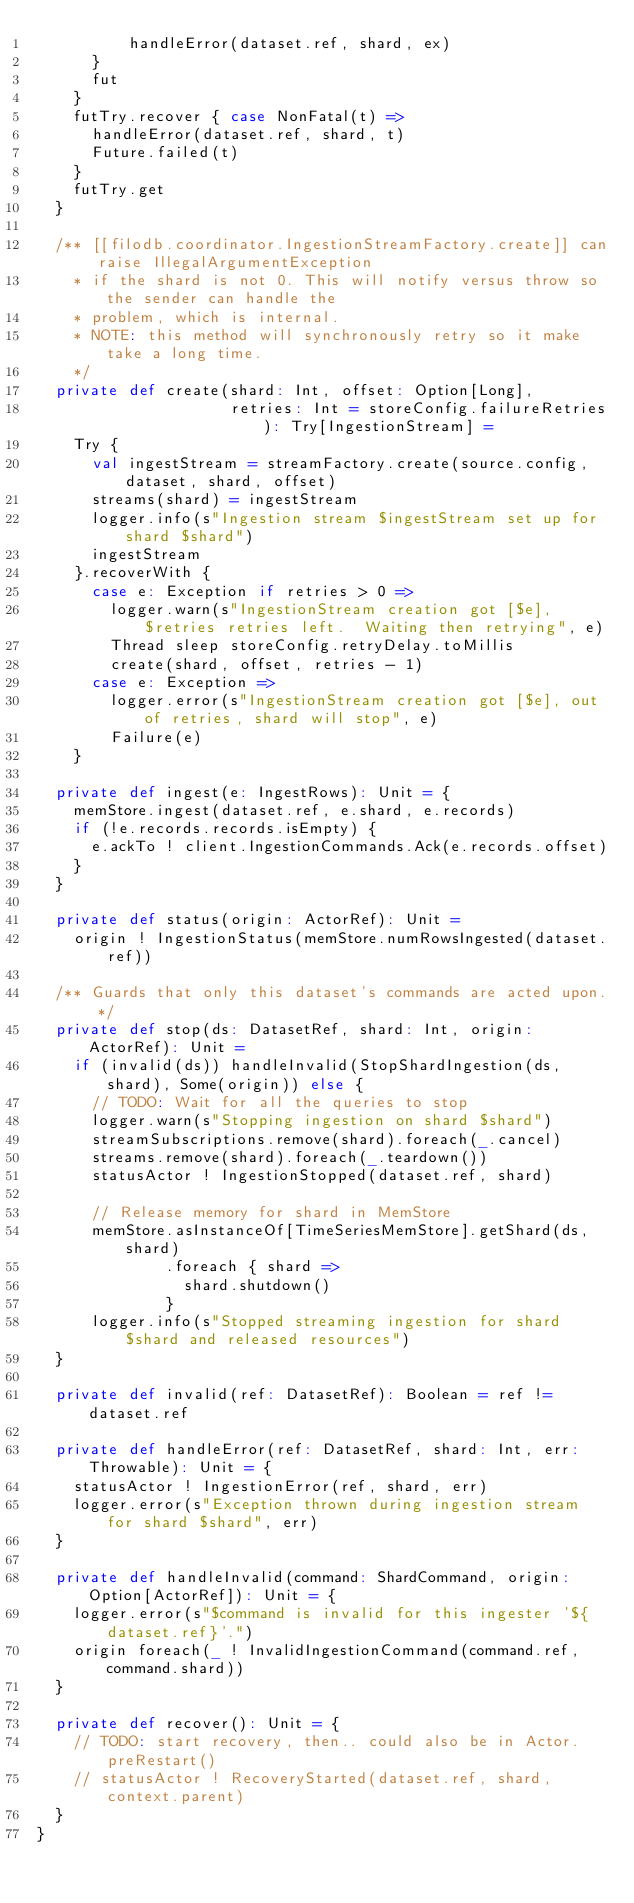<code> <loc_0><loc_0><loc_500><loc_500><_Scala_>          handleError(dataset.ref, shard, ex)
      }
      fut
    }
    futTry.recover { case NonFatal(t) =>
      handleError(dataset.ref, shard, t)
      Future.failed(t)
    }
    futTry.get
  }

  /** [[filodb.coordinator.IngestionStreamFactory.create]] can raise IllegalArgumentException
    * if the shard is not 0. This will notify versus throw so the sender can handle the
    * problem, which is internal.
    * NOTE: this method will synchronously retry so it make take a long time.
    */
  private def create(shard: Int, offset: Option[Long],
                     retries: Int = storeConfig.failureRetries): Try[IngestionStream] =
    Try {
      val ingestStream = streamFactory.create(source.config, dataset, shard, offset)
      streams(shard) = ingestStream
      logger.info(s"Ingestion stream $ingestStream set up for shard $shard")
      ingestStream
    }.recoverWith {
      case e: Exception if retries > 0 =>
        logger.warn(s"IngestionStream creation got [$e], $retries retries left.  Waiting then retrying", e)
        Thread sleep storeConfig.retryDelay.toMillis
        create(shard, offset, retries - 1)
      case e: Exception =>
        logger.error(s"IngestionStream creation got [$e], out of retries, shard will stop", e)
        Failure(e)
    }

  private def ingest(e: IngestRows): Unit = {
    memStore.ingest(dataset.ref, e.shard, e.records)
    if (!e.records.records.isEmpty) {
      e.ackTo ! client.IngestionCommands.Ack(e.records.offset)
    }
  }

  private def status(origin: ActorRef): Unit =
    origin ! IngestionStatus(memStore.numRowsIngested(dataset.ref))

  /** Guards that only this dataset's commands are acted upon. */
  private def stop(ds: DatasetRef, shard: Int, origin: ActorRef): Unit =
    if (invalid(ds)) handleInvalid(StopShardIngestion(ds, shard), Some(origin)) else {
      // TODO: Wait for all the queries to stop
      logger.warn(s"Stopping ingestion on shard $shard")
      streamSubscriptions.remove(shard).foreach(_.cancel)
      streams.remove(shard).foreach(_.teardown())
      statusActor ! IngestionStopped(dataset.ref, shard)

      // Release memory for shard in MemStore
      memStore.asInstanceOf[TimeSeriesMemStore].getShard(ds, shard)
              .foreach { shard =>
                shard.shutdown()
              }
      logger.info(s"Stopped streaming ingestion for shard $shard and released resources")
  }

  private def invalid(ref: DatasetRef): Boolean = ref != dataset.ref

  private def handleError(ref: DatasetRef, shard: Int, err: Throwable): Unit = {
    statusActor ! IngestionError(ref, shard, err)
    logger.error(s"Exception thrown during ingestion stream for shard $shard", err)
  }

  private def handleInvalid(command: ShardCommand, origin: Option[ActorRef]): Unit = {
    logger.error(s"$command is invalid for this ingester '${dataset.ref}'.")
    origin foreach(_ ! InvalidIngestionCommand(command.ref, command.shard))
  }

  private def recover(): Unit = {
    // TODO: start recovery, then.. could also be in Actor.preRestart()
    // statusActor ! RecoveryStarted(dataset.ref, shard, context.parent)
  }
}</code> 